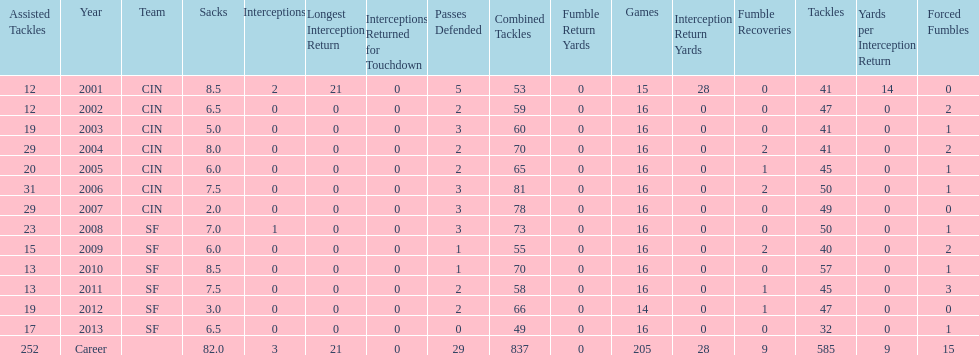What is the average number of tackles this player has had over his career? 45. 